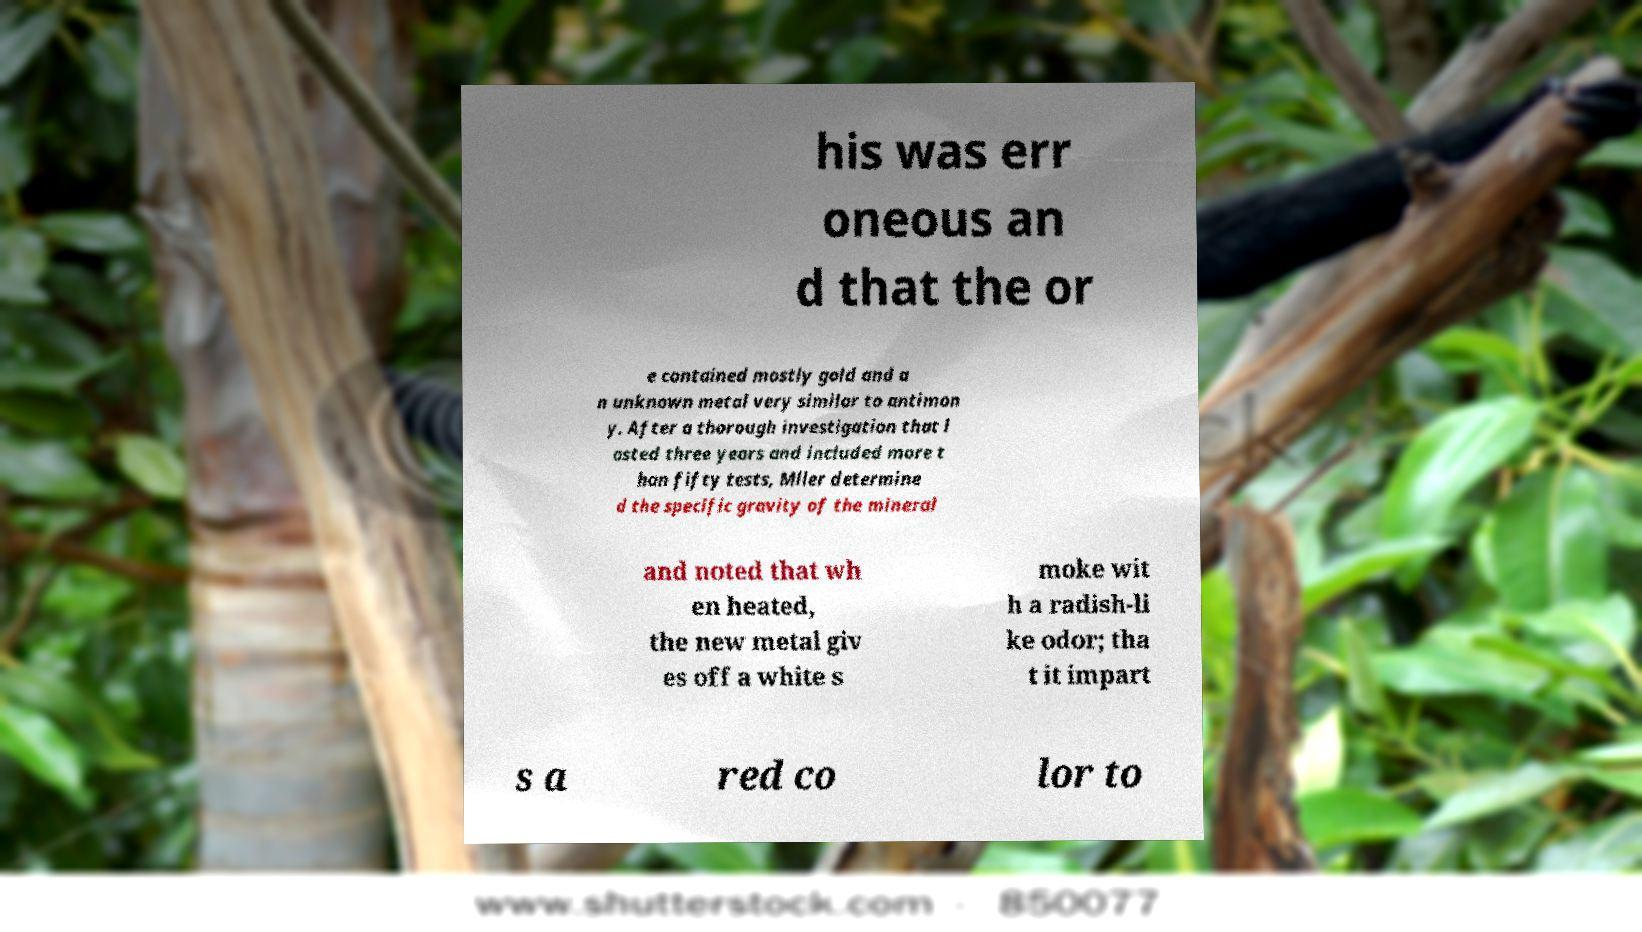Can you accurately transcribe the text from the provided image for me? his was err oneous an d that the or e contained mostly gold and a n unknown metal very similar to antimon y. After a thorough investigation that l asted three years and included more t han fifty tests, Mller determine d the specific gravity of the mineral and noted that wh en heated, the new metal giv es off a white s moke wit h a radish-li ke odor; tha t it impart s a red co lor to 